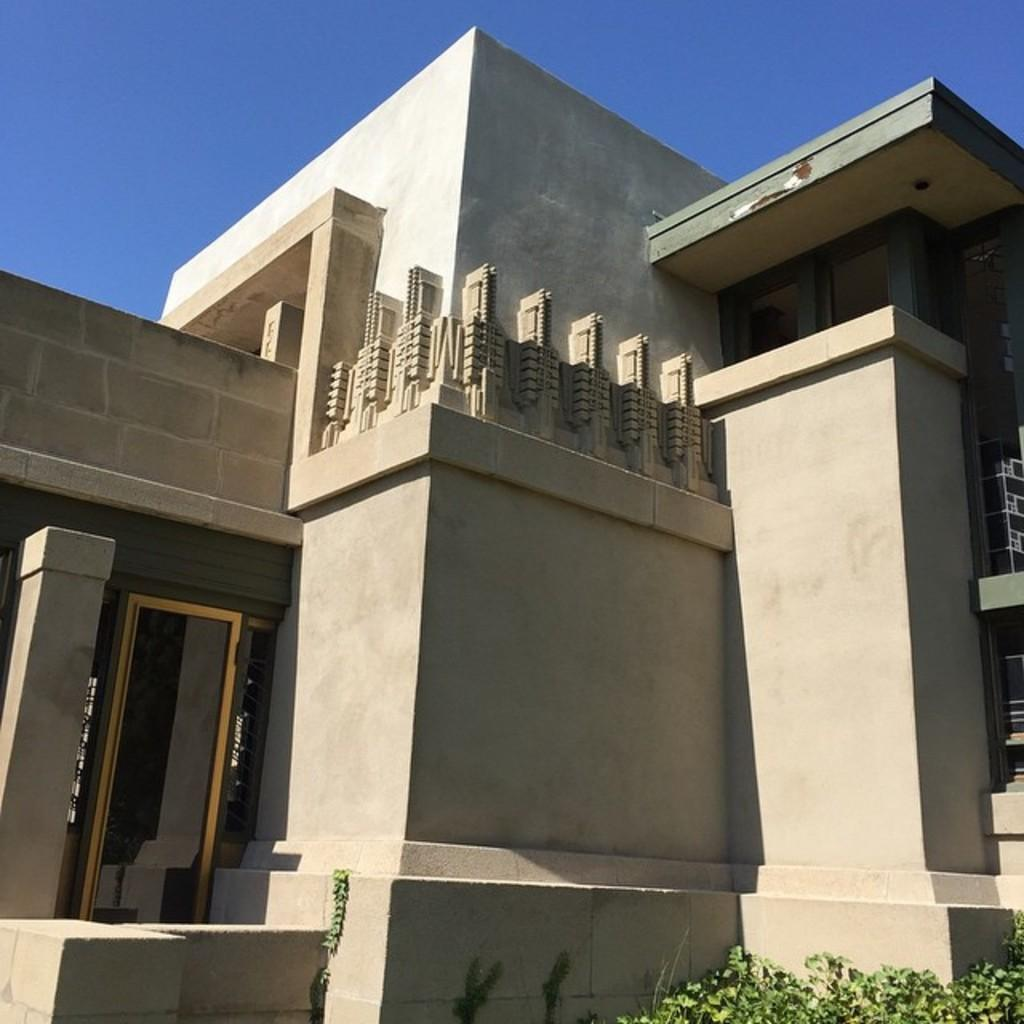What type of structure is visible in the image? There is a house in the image. What other elements can be seen in the image besides the house? There are plants visible in the image. What is visible in the background of the image? The sky is visible in the image. Can you see any children playing with blood in the image? There is no mention of children or blood in the image; it features a house and plants with a visible sky. 